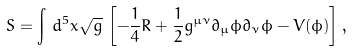<formula> <loc_0><loc_0><loc_500><loc_500>S = \int \, d ^ { 5 } x \sqrt { g } \, \left [ - \frac { 1 } { 4 } R + \frac { 1 } { 2 } g ^ { \mu \nu } \partial _ { \mu } \phi \partial _ { \nu } \phi - V ( \phi ) \right ] ,</formula> 